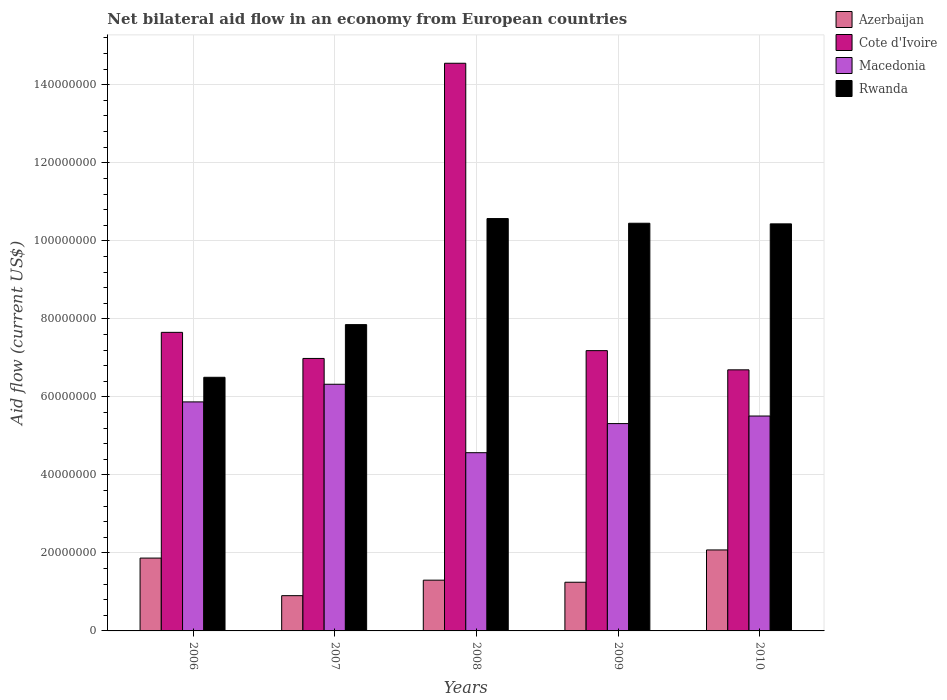How many groups of bars are there?
Ensure brevity in your answer.  5. What is the label of the 1st group of bars from the left?
Your response must be concise. 2006. What is the net bilateral aid flow in Cote d'Ivoire in 2006?
Ensure brevity in your answer.  7.65e+07. Across all years, what is the maximum net bilateral aid flow in Macedonia?
Offer a terse response. 6.32e+07. Across all years, what is the minimum net bilateral aid flow in Cote d'Ivoire?
Ensure brevity in your answer.  6.69e+07. In which year was the net bilateral aid flow in Cote d'Ivoire maximum?
Keep it short and to the point. 2008. What is the total net bilateral aid flow in Rwanda in the graph?
Offer a very short reply. 4.58e+08. What is the difference between the net bilateral aid flow in Cote d'Ivoire in 2006 and that in 2007?
Make the answer very short. 6.69e+06. What is the difference between the net bilateral aid flow in Cote d'Ivoire in 2010 and the net bilateral aid flow in Rwanda in 2006?
Ensure brevity in your answer.  1.91e+06. What is the average net bilateral aid flow in Rwanda per year?
Give a very brief answer. 9.16e+07. In the year 2008, what is the difference between the net bilateral aid flow in Cote d'Ivoire and net bilateral aid flow in Rwanda?
Give a very brief answer. 3.98e+07. What is the ratio of the net bilateral aid flow in Azerbaijan in 2006 to that in 2010?
Offer a very short reply. 0.9. Is the net bilateral aid flow in Rwanda in 2006 less than that in 2008?
Offer a very short reply. Yes. What is the difference between the highest and the second highest net bilateral aid flow in Macedonia?
Your answer should be compact. 4.52e+06. What is the difference between the highest and the lowest net bilateral aid flow in Azerbaijan?
Your answer should be compact. 1.17e+07. Is the sum of the net bilateral aid flow in Cote d'Ivoire in 2009 and 2010 greater than the maximum net bilateral aid flow in Rwanda across all years?
Offer a terse response. Yes. What does the 3rd bar from the left in 2007 represents?
Give a very brief answer. Macedonia. What does the 4th bar from the right in 2006 represents?
Your answer should be compact. Azerbaijan. Are all the bars in the graph horizontal?
Offer a terse response. No. How many years are there in the graph?
Provide a succinct answer. 5. What is the difference between two consecutive major ticks on the Y-axis?
Your answer should be compact. 2.00e+07. Are the values on the major ticks of Y-axis written in scientific E-notation?
Ensure brevity in your answer.  No. Does the graph contain grids?
Ensure brevity in your answer.  Yes. Where does the legend appear in the graph?
Ensure brevity in your answer.  Top right. How are the legend labels stacked?
Your answer should be very brief. Vertical. What is the title of the graph?
Keep it short and to the point. Net bilateral aid flow in an economy from European countries. Does "Isle of Man" appear as one of the legend labels in the graph?
Provide a succinct answer. No. What is the label or title of the X-axis?
Offer a very short reply. Years. What is the label or title of the Y-axis?
Give a very brief answer. Aid flow (current US$). What is the Aid flow (current US$) of Azerbaijan in 2006?
Keep it short and to the point. 1.87e+07. What is the Aid flow (current US$) in Cote d'Ivoire in 2006?
Offer a terse response. 7.65e+07. What is the Aid flow (current US$) in Macedonia in 2006?
Your answer should be very brief. 5.87e+07. What is the Aid flow (current US$) of Rwanda in 2006?
Your answer should be compact. 6.50e+07. What is the Aid flow (current US$) of Azerbaijan in 2007?
Provide a succinct answer. 9.04e+06. What is the Aid flow (current US$) of Cote d'Ivoire in 2007?
Provide a short and direct response. 6.98e+07. What is the Aid flow (current US$) in Macedonia in 2007?
Offer a very short reply. 6.32e+07. What is the Aid flow (current US$) in Rwanda in 2007?
Give a very brief answer. 7.85e+07. What is the Aid flow (current US$) of Azerbaijan in 2008?
Keep it short and to the point. 1.30e+07. What is the Aid flow (current US$) of Cote d'Ivoire in 2008?
Your response must be concise. 1.46e+08. What is the Aid flow (current US$) of Macedonia in 2008?
Offer a terse response. 4.57e+07. What is the Aid flow (current US$) in Rwanda in 2008?
Your answer should be compact. 1.06e+08. What is the Aid flow (current US$) in Azerbaijan in 2009?
Give a very brief answer. 1.25e+07. What is the Aid flow (current US$) of Cote d'Ivoire in 2009?
Offer a terse response. 7.18e+07. What is the Aid flow (current US$) of Macedonia in 2009?
Provide a short and direct response. 5.32e+07. What is the Aid flow (current US$) of Rwanda in 2009?
Provide a succinct answer. 1.05e+08. What is the Aid flow (current US$) in Azerbaijan in 2010?
Offer a very short reply. 2.08e+07. What is the Aid flow (current US$) in Cote d'Ivoire in 2010?
Give a very brief answer. 6.69e+07. What is the Aid flow (current US$) in Macedonia in 2010?
Ensure brevity in your answer.  5.51e+07. What is the Aid flow (current US$) in Rwanda in 2010?
Give a very brief answer. 1.04e+08. Across all years, what is the maximum Aid flow (current US$) in Azerbaijan?
Keep it short and to the point. 2.08e+07. Across all years, what is the maximum Aid flow (current US$) in Cote d'Ivoire?
Offer a terse response. 1.46e+08. Across all years, what is the maximum Aid flow (current US$) of Macedonia?
Offer a terse response. 6.32e+07. Across all years, what is the maximum Aid flow (current US$) of Rwanda?
Your response must be concise. 1.06e+08. Across all years, what is the minimum Aid flow (current US$) of Azerbaijan?
Your response must be concise. 9.04e+06. Across all years, what is the minimum Aid flow (current US$) of Cote d'Ivoire?
Keep it short and to the point. 6.69e+07. Across all years, what is the minimum Aid flow (current US$) in Macedonia?
Provide a short and direct response. 4.57e+07. Across all years, what is the minimum Aid flow (current US$) of Rwanda?
Offer a very short reply. 6.50e+07. What is the total Aid flow (current US$) of Azerbaijan in the graph?
Give a very brief answer. 7.40e+07. What is the total Aid flow (current US$) of Cote d'Ivoire in the graph?
Your answer should be very brief. 4.31e+08. What is the total Aid flow (current US$) of Macedonia in the graph?
Your answer should be compact. 2.76e+08. What is the total Aid flow (current US$) in Rwanda in the graph?
Provide a succinct answer. 4.58e+08. What is the difference between the Aid flow (current US$) in Azerbaijan in 2006 and that in 2007?
Give a very brief answer. 9.63e+06. What is the difference between the Aid flow (current US$) of Cote d'Ivoire in 2006 and that in 2007?
Give a very brief answer. 6.69e+06. What is the difference between the Aid flow (current US$) in Macedonia in 2006 and that in 2007?
Your response must be concise. -4.52e+06. What is the difference between the Aid flow (current US$) in Rwanda in 2006 and that in 2007?
Give a very brief answer. -1.35e+07. What is the difference between the Aid flow (current US$) in Azerbaijan in 2006 and that in 2008?
Ensure brevity in your answer.  5.66e+06. What is the difference between the Aid flow (current US$) in Cote d'Ivoire in 2006 and that in 2008?
Provide a succinct answer. -6.90e+07. What is the difference between the Aid flow (current US$) of Macedonia in 2006 and that in 2008?
Provide a succinct answer. 1.30e+07. What is the difference between the Aid flow (current US$) of Rwanda in 2006 and that in 2008?
Make the answer very short. -4.07e+07. What is the difference between the Aid flow (current US$) in Azerbaijan in 2006 and that in 2009?
Make the answer very short. 6.19e+06. What is the difference between the Aid flow (current US$) in Cote d'Ivoire in 2006 and that in 2009?
Your answer should be very brief. 4.69e+06. What is the difference between the Aid flow (current US$) of Macedonia in 2006 and that in 2009?
Keep it short and to the point. 5.56e+06. What is the difference between the Aid flow (current US$) of Rwanda in 2006 and that in 2009?
Your response must be concise. -3.95e+07. What is the difference between the Aid flow (current US$) in Azerbaijan in 2006 and that in 2010?
Provide a short and direct response. -2.09e+06. What is the difference between the Aid flow (current US$) in Cote d'Ivoire in 2006 and that in 2010?
Provide a short and direct response. 9.61e+06. What is the difference between the Aid flow (current US$) in Macedonia in 2006 and that in 2010?
Keep it short and to the point. 3.62e+06. What is the difference between the Aid flow (current US$) of Rwanda in 2006 and that in 2010?
Your answer should be compact. -3.93e+07. What is the difference between the Aid flow (current US$) of Azerbaijan in 2007 and that in 2008?
Make the answer very short. -3.97e+06. What is the difference between the Aid flow (current US$) of Cote d'Ivoire in 2007 and that in 2008?
Provide a short and direct response. -7.57e+07. What is the difference between the Aid flow (current US$) of Macedonia in 2007 and that in 2008?
Give a very brief answer. 1.75e+07. What is the difference between the Aid flow (current US$) of Rwanda in 2007 and that in 2008?
Your answer should be very brief. -2.72e+07. What is the difference between the Aid flow (current US$) of Azerbaijan in 2007 and that in 2009?
Your answer should be very brief. -3.44e+06. What is the difference between the Aid flow (current US$) in Macedonia in 2007 and that in 2009?
Keep it short and to the point. 1.01e+07. What is the difference between the Aid flow (current US$) of Rwanda in 2007 and that in 2009?
Give a very brief answer. -2.60e+07. What is the difference between the Aid flow (current US$) of Azerbaijan in 2007 and that in 2010?
Ensure brevity in your answer.  -1.17e+07. What is the difference between the Aid flow (current US$) of Cote d'Ivoire in 2007 and that in 2010?
Keep it short and to the point. 2.92e+06. What is the difference between the Aid flow (current US$) of Macedonia in 2007 and that in 2010?
Offer a very short reply. 8.14e+06. What is the difference between the Aid flow (current US$) of Rwanda in 2007 and that in 2010?
Offer a terse response. -2.58e+07. What is the difference between the Aid flow (current US$) of Azerbaijan in 2008 and that in 2009?
Offer a terse response. 5.30e+05. What is the difference between the Aid flow (current US$) of Cote d'Ivoire in 2008 and that in 2009?
Your response must be concise. 7.37e+07. What is the difference between the Aid flow (current US$) of Macedonia in 2008 and that in 2009?
Keep it short and to the point. -7.46e+06. What is the difference between the Aid flow (current US$) in Rwanda in 2008 and that in 2009?
Provide a succinct answer. 1.20e+06. What is the difference between the Aid flow (current US$) of Azerbaijan in 2008 and that in 2010?
Offer a very short reply. -7.75e+06. What is the difference between the Aid flow (current US$) of Cote d'Ivoire in 2008 and that in 2010?
Your answer should be very brief. 7.86e+07. What is the difference between the Aid flow (current US$) of Macedonia in 2008 and that in 2010?
Your answer should be very brief. -9.40e+06. What is the difference between the Aid flow (current US$) of Rwanda in 2008 and that in 2010?
Give a very brief answer. 1.36e+06. What is the difference between the Aid flow (current US$) in Azerbaijan in 2009 and that in 2010?
Provide a succinct answer. -8.28e+06. What is the difference between the Aid flow (current US$) of Cote d'Ivoire in 2009 and that in 2010?
Give a very brief answer. 4.92e+06. What is the difference between the Aid flow (current US$) of Macedonia in 2009 and that in 2010?
Provide a succinct answer. -1.94e+06. What is the difference between the Aid flow (current US$) in Azerbaijan in 2006 and the Aid flow (current US$) in Cote d'Ivoire in 2007?
Ensure brevity in your answer.  -5.12e+07. What is the difference between the Aid flow (current US$) in Azerbaijan in 2006 and the Aid flow (current US$) in Macedonia in 2007?
Your answer should be very brief. -4.46e+07. What is the difference between the Aid flow (current US$) of Azerbaijan in 2006 and the Aid flow (current US$) of Rwanda in 2007?
Make the answer very short. -5.98e+07. What is the difference between the Aid flow (current US$) in Cote d'Ivoire in 2006 and the Aid flow (current US$) in Macedonia in 2007?
Keep it short and to the point. 1.33e+07. What is the difference between the Aid flow (current US$) in Cote d'Ivoire in 2006 and the Aid flow (current US$) in Rwanda in 2007?
Provide a succinct answer. -1.98e+06. What is the difference between the Aid flow (current US$) of Macedonia in 2006 and the Aid flow (current US$) of Rwanda in 2007?
Your answer should be very brief. -1.98e+07. What is the difference between the Aid flow (current US$) of Azerbaijan in 2006 and the Aid flow (current US$) of Cote d'Ivoire in 2008?
Your answer should be very brief. -1.27e+08. What is the difference between the Aid flow (current US$) in Azerbaijan in 2006 and the Aid flow (current US$) in Macedonia in 2008?
Your response must be concise. -2.70e+07. What is the difference between the Aid flow (current US$) of Azerbaijan in 2006 and the Aid flow (current US$) of Rwanda in 2008?
Your answer should be compact. -8.70e+07. What is the difference between the Aid flow (current US$) of Cote d'Ivoire in 2006 and the Aid flow (current US$) of Macedonia in 2008?
Offer a very short reply. 3.08e+07. What is the difference between the Aid flow (current US$) in Cote d'Ivoire in 2006 and the Aid flow (current US$) in Rwanda in 2008?
Offer a very short reply. -2.92e+07. What is the difference between the Aid flow (current US$) of Macedonia in 2006 and the Aid flow (current US$) of Rwanda in 2008?
Offer a very short reply. -4.70e+07. What is the difference between the Aid flow (current US$) in Azerbaijan in 2006 and the Aid flow (current US$) in Cote d'Ivoire in 2009?
Your answer should be compact. -5.32e+07. What is the difference between the Aid flow (current US$) of Azerbaijan in 2006 and the Aid flow (current US$) of Macedonia in 2009?
Keep it short and to the point. -3.45e+07. What is the difference between the Aid flow (current US$) in Azerbaijan in 2006 and the Aid flow (current US$) in Rwanda in 2009?
Your answer should be compact. -8.58e+07. What is the difference between the Aid flow (current US$) in Cote d'Ivoire in 2006 and the Aid flow (current US$) in Macedonia in 2009?
Ensure brevity in your answer.  2.34e+07. What is the difference between the Aid flow (current US$) in Cote d'Ivoire in 2006 and the Aid flow (current US$) in Rwanda in 2009?
Make the answer very short. -2.80e+07. What is the difference between the Aid flow (current US$) of Macedonia in 2006 and the Aid flow (current US$) of Rwanda in 2009?
Make the answer very short. -4.58e+07. What is the difference between the Aid flow (current US$) of Azerbaijan in 2006 and the Aid flow (current US$) of Cote d'Ivoire in 2010?
Offer a terse response. -4.83e+07. What is the difference between the Aid flow (current US$) of Azerbaijan in 2006 and the Aid flow (current US$) of Macedonia in 2010?
Your answer should be very brief. -3.64e+07. What is the difference between the Aid flow (current US$) in Azerbaijan in 2006 and the Aid flow (current US$) in Rwanda in 2010?
Give a very brief answer. -8.57e+07. What is the difference between the Aid flow (current US$) of Cote d'Ivoire in 2006 and the Aid flow (current US$) of Macedonia in 2010?
Ensure brevity in your answer.  2.14e+07. What is the difference between the Aid flow (current US$) in Cote d'Ivoire in 2006 and the Aid flow (current US$) in Rwanda in 2010?
Your response must be concise. -2.78e+07. What is the difference between the Aid flow (current US$) of Macedonia in 2006 and the Aid flow (current US$) of Rwanda in 2010?
Provide a succinct answer. -4.56e+07. What is the difference between the Aid flow (current US$) in Azerbaijan in 2007 and the Aid flow (current US$) in Cote d'Ivoire in 2008?
Ensure brevity in your answer.  -1.36e+08. What is the difference between the Aid flow (current US$) of Azerbaijan in 2007 and the Aid flow (current US$) of Macedonia in 2008?
Offer a very short reply. -3.66e+07. What is the difference between the Aid flow (current US$) of Azerbaijan in 2007 and the Aid flow (current US$) of Rwanda in 2008?
Keep it short and to the point. -9.67e+07. What is the difference between the Aid flow (current US$) in Cote d'Ivoire in 2007 and the Aid flow (current US$) in Macedonia in 2008?
Provide a succinct answer. 2.42e+07. What is the difference between the Aid flow (current US$) in Cote d'Ivoire in 2007 and the Aid flow (current US$) in Rwanda in 2008?
Offer a very short reply. -3.59e+07. What is the difference between the Aid flow (current US$) in Macedonia in 2007 and the Aid flow (current US$) in Rwanda in 2008?
Offer a terse response. -4.25e+07. What is the difference between the Aid flow (current US$) in Azerbaijan in 2007 and the Aid flow (current US$) in Cote d'Ivoire in 2009?
Offer a very short reply. -6.28e+07. What is the difference between the Aid flow (current US$) of Azerbaijan in 2007 and the Aid flow (current US$) of Macedonia in 2009?
Make the answer very short. -4.41e+07. What is the difference between the Aid flow (current US$) of Azerbaijan in 2007 and the Aid flow (current US$) of Rwanda in 2009?
Your response must be concise. -9.55e+07. What is the difference between the Aid flow (current US$) of Cote d'Ivoire in 2007 and the Aid flow (current US$) of Macedonia in 2009?
Keep it short and to the point. 1.67e+07. What is the difference between the Aid flow (current US$) in Cote d'Ivoire in 2007 and the Aid flow (current US$) in Rwanda in 2009?
Your answer should be compact. -3.47e+07. What is the difference between the Aid flow (current US$) of Macedonia in 2007 and the Aid flow (current US$) of Rwanda in 2009?
Provide a short and direct response. -4.13e+07. What is the difference between the Aid flow (current US$) of Azerbaijan in 2007 and the Aid flow (current US$) of Cote d'Ivoire in 2010?
Your answer should be compact. -5.79e+07. What is the difference between the Aid flow (current US$) in Azerbaijan in 2007 and the Aid flow (current US$) in Macedonia in 2010?
Offer a terse response. -4.60e+07. What is the difference between the Aid flow (current US$) of Azerbaijan in 2007 and the Aid flow (current US$) of Rwanda in 2010?
Make the answer very short. -9.53e+07. What is the difference between the Aid flow (current US$) of Cote d'Ivoire in 2007 and the Aid flow (current US$) of Macedonia in 2010?
Keep it short and to the point. 1.48e+07. What is the difference between the Aid flow (current US$) of Cote d'Ivoire in 2007 and the Aid flow (current US$) of Rwanda in 2010?
Offer a terse response. -3.45e+07. What is the difference between the Aid flow (current US$) in Macedonia in 2007 and the Aid flow (current US$) in Rwanda in 2010?
Give a very brief answer. -4.11e+07. What is the difference between the Aid flow (current US$) in Azerbaijan in 2008 and the Aid flow (current US$) in Cote d'Ivoire in 2009?
Ensure brevity in your answer.  -5.88e+07. What is the difference between the Aid flow (current US$) in Azerbaijan in 2008 and the Aid flow (current US$) in Macedonia in 2009?
Your response must be concise. -4.01e+07. What is the difference between the Aid flow (current US$) in Azerbaijan in 2008 and the Aid flow (current US$) in Rwanda in 2009?
Provide a succinct answer. -9.15e+07. What is the difference between the Aid flow (current US$) of Cote d'Ivoire in 2008 and the Aid flow (current US$) of Macedonia in 2009?
Provide a short and direct response. 9.24e+07. What is the difference between the Aid flow (current US$) of Cote d'Ivoire in 2008 and the Aid flow (current US$) of Rwanda in 2009?
Your answer should be very brief. 4.10e+07. What is the difference between the Aid flow (current US$) of Macedonia in 2008 and the Aid flow (current US$) of Rwanda in 2009?
Your answer should be compact. -5.88e+07. What is the difference between the Aid flow (current US$) of Azerbaijan in 2008 and the Aid flow (current US$) of Cote d'Ivoire in 2010?
Keep it short and to the point. -5.39e+07. What is the difference between the Aid flow (current US$) of Azerbaijan in 2008 and the Aid flow (current US$) of Macedonia in 2010?
Give a very brief answer. -4.21e+07. What is the difference between the Aid flow (current US$) in Azerbaijan in 2008 and the Aid flow (current US$) in Rwanda in 2010?
Provide a succinct answer. -9.13e+07. What is the difference between the Aid flow (current US$) of Cote d'Ivoire in 2008 and the Aid flow (current US$) of Macedonia in 2010?
Make the answer very short. 9.04e+07. What is the difference between the Aid flow (current US$) of Cote d'Ivoire in 2008 and the Aid flow (current US$) of Rwanda in 2010?
Your response must be concise. 4.12e+07. What is the difference between the Aid flow (current US$) of Macedonia in 2008 and the Aid flow (current US$) of Rwanda in 2010?
Offer a terse response. -5.87e+07. What is the difference between the Aid flow (current US$) in Azerbaijan in 2009 and the Aid flow (current US$) in Cote d'Ivoire in 2010?
Provide a succinct answer. -5.44e+07. What is the difference between the Aid flow (current US$) in Azerbaijan in 2009 and the Aid flow (current US$) in Macedonia in 2010?
Give a very brief answer. -4.26e+07. What is the difference between the Aid flow (current US$) in Azerbaijan in 2009 and the Aid flow (current US$) in Rwanda in 2010?
Provide a succinct answer. -9.19e+07. What is the difference between the Aid flow (current US$) of Cote d'Ivoire in 2009 and the Aid flow (current US$) of Macedonia in 2010?
Provide a short and direct response. 1.68e+07. What is the difference between the Aid flow (current US$) in Cote d'Ivoire in 2009 and the Aid flow (current US$) in Rwanda in 2010?
Provide a short and direct response. -3.25e+07. What is the difference between the Aid flow (current US$) of Macedonia in 2009 and the Aid flow (current US$) of Rwanda in 2010?
Your answer should be very brief. -5.12e+07. What is the average Aid flow (current US$) of Azerbaijan per year?
Make the answer very short. 1.48e+07. What is the average Aid flow (current US$) of Cote d'Ivoire per year?
Provide a succinct answer. 8.61e+07. What is the average Aid flow (current US$) of Macedonia per year?
Your answer should be compact. 5.52e+07. What is the average Aid flow (current US$) in Rwanda per year?
Give a very brief answer. 9.16e+07. In the year 2006, what is the difference between the Aid flow (current US$) of Azerbaijan and Aid flow (current US$) of Cote d'Ivoire?
Ensure brevity in your answer.  -5.79e+07. In the year 2006, what is the difference between the Aid flow (current US$) of Azerbaijan and Aid flow (current US$) of Macedonia?
Ensure brevity in your answer.  -4.00e+07. In the year 2006, what is the difference between the Aid flow (current US$) of Azerbaijan and Aid flow (current US$) of Rwanda?
Your answer should be very brief. -4.64e+07. In the year 2006, what is the difference between the Aid flow (current US$) of Cote d'Ivoire and Aid flow (current US$) of Macedonia?
Your response must be concise. 1.78e+07. In the year 2006, what is the difference between the Aid flow (current US$) of Cote d'Ivoire and Aid flow (current US$) of Rwanda?
Provide a short and direct response. 1.15e+07. In the year 2006, what is the difference between the Aid flow (current US$) of Macedonia and Aid flow (current US$) of Rwanda?
Provide a short and direct response. -6.31e+06. In the year 2007, what is the difference between the Aid flow (current US$) in Azerbaijan and Aid flow (current US$) in Cote d'Ivoire?
Provide a succinct answer. -6.08e+07. In the year 2007, what is the difference between the Aid flow (current US$) of Azerbaijan and Aid flow (current US$) of Macedonia?
Offer a very short reply. -5.42e+07. In the year 2007, what is the difference between the Aid flow (current US$) of Azerbaijan and Aid flow (current US$) of Rwanda?
Offer a terse response. -6.95e+07. In the year 2007, what is the difference between the Aid flow (current US$) of Cote d'Ivoire and Aid flow (current US$) of Macedonia?
Your answer should be very brief. 6.62e+06. In the year 2007, what is the difference between the Aid flow (current US$) of Cote d'Ivoire and Aid flow (current US$) of Rwanda?
Provide a succinct answer. -8.67e+06. In the year 2007, what is the difference between the Aid flow (current US$) of Macedonia and Aid flow (current US$) of Rwanda?
Offer a terse response. -1.53e+07. In the year 2008, what is the difference between the Aid flow (current US$) of Azerbaijan and Aid flow (current US$) of Cote d'Ivoire?
Your answer should be very brief. -1.33e+08. In the year 2008, what is the difference between the Aid flow (current US$) of Azerbaijan and Aid flow (current US$) of Macedonia?
Ensure brevity in your answer.  -3.27e+07. In the year 2008, what is the difference between the Aid flow (current US$) of Azerbaijan and Aid flow (current US$) of Rwanda?
Your answer should be compact. -9.27e+07. In the year 2008, what is the difference between the Aid flow (current US$) in Cote d'Ivoire and Aid flow (current US$) in Macedonia?
Keep it short and to the point. 9.98e+07. In the year 2008, what is the difference between the Aid flow (current US$) in Cote d'Ivoire and Aid flow (current US$) in Rwanda?
Your answer should be very brief. 3.98e+07. In the year 2008, what is the difference between the Aid flow (current US$) in Macedonia and Aid flow (current US$) in Rwanda?
Provide a succinct answer. -6.00e+07. In the year 2009, what is the difference between the Aid flow (current US$) of Azerbaijan and Aid flow (current US$) of Cote d'Ivoire?
Make the answer very short. -5.94e+07. In the year 2009, what is the difference between the Aid flow (current US$) in Azerbaijan and Aid flow (current US$) in Macedonia?
Give a very brief answer. -4.07e+07. In the year 2009, what is the difference between the Aid flow (current US$) of Azerbaijan and Aid flow (current US$) of Rwanda?
Your answer should be very brief. -9.20e+07. In the year 2009, what is the difference between the Aid flow (current US$) in Cote d'Ivoire and Aid flow (current US$) in Macedonia?
Keep it short and to the point. 1.87e+07. In the year 2009, what is the difference between the Aid flow (current US$) in Cote d'Ivoire and Aid flow (current US$) in Rwanda?
Make the answer very short. -3.27e+07. In the year 2009, what is the difference between the Aid flow (current US$) of Macedonia and Aid flow (current US$) of Rwanda?
Provide a succinct answer. -5.14e+07. In the year 2010, what is the difference between the Aid flow (current US$) of Azerbaijan and Aid flow (current US$) of Cote d'Ivoire?
Ensure brevity in your answer.  -4.62e+07. In the year 2010, what is the difference between the Aid flow (current US$) of Azerbaijan and Aid flow (current US$) of Macedonia?
Your answer should be very brief. -3.43e+07. In the year 2010, what is the difference between the Aid flow (current US$) in Azerbaijan and Aid flow (current US$) in Rwanda?
Offer a very short reply. -8.36e+07. In the year 2010, what is the difference between the Aid flow (current US$) of Cote d'Ivoire and Aid flow (current US$) of Macedonia?
Offer a terse response. 1.18e+07. In the year 2010, what is the difference between the Aid flow (current US$) in Cote d'Ivoire and Aid flow (current US$) in Rwanda?
Ensure brevity in your answer.  -3.74e+07. In the year 2010, what is the difference between the Aid flow (current US$) of Macedonia and Aid flow (current US$) of Rwanda?
Offer a very short reply. -4.93e+07. What is the ratio of the Aid flow (current US$) of Azerbaijan in 2006 to that in 2007?
Your answer should be very brief. 2.07. What is the ratio of the Aid flow (current US$) of Cote d'Ivoire in 2006 to that in 2007?
Give a very brief answer. 1.1. What is the ratio of the Aid flow (current US$) in Macedonia in 2006 to that in 2007?
Ensure brevity in your answer.  0.93. What is the ratio of the Aid flow (current US$) in Rwanda in 2006 to that in 2007?
Offer a terse response. 0.83. What is the ratio of the Aid flow (current US$) of Azerbaijan in 2006 to that in 2008?
Ensure brevity in your answer.  1.44. What is the ratio of the Aid flow (current US$) of Cote d'Ivoire in 2006 to that in 2008?
Ensure brevity in your answer.  0.53. What is the ratio of the Aid flow (current US$) in Macedonia in 2006 to that in 2008?
Make the answer very short. 1.28. What is the ratio of the Aid flow (current US$) of Rwanda in 2006 to that in 2008?
Your answer should be very brief. 0.62. What is the ratio of the Aid flow (current US$) of Azerbaijan in 2006 to that in 2009?
Offer a terse response. 1.5. What is the ratio of the Aid flow (current US$) of Cote d'Ivoire in 2006 to that in 2009?
Ensure brevity in your answer.  1.07. What is the ratio of the Aid flow (current US$) of Macedonia in 2006 to that in 2009?
Your answer should be compact. 1.1. What is the ratio of the Aid flow (current US$) in Rwanda in 2006 to that in 2009?
Make the answer very short. 0.62. What is the ratio of the Aid flow (current US$) of Azerbaijan in 2006 to that in 2010?
Provide a succinct answer. 0.9. What is the ratio of the Aid flow (current US$) in Cote d'Ivoire in 2006 to that in 2010?
Offer a very short reply. 1.14. What is the ratio of the Aid flow (current US$) in Macedonia in 2006 to that in 2010?
Your answer should be very brief. 1.07. What is the ratio of the Aid flow (current US$) of Rwanda in 2006 to that in 2010?
Your answer should be very brief. 0.62. What is the ratio of the Aid flow (current US$) in Azerbaijan in 2007 to that in 2008?
Provide a short and direct response. 0.69. What is the ratio of the Aid flow (current US$) of Cote d'Ivoire in 2007 to that in 2008?
Provide a short and direct response. 0.48. What is the ratio of the Aid flow (current US$) of Macedonia in 2007 to that in 2008?
Offer a very short reply. 1.38. What is the ratio of the Aid flow (current US$) in Rwanda in 2007 to that in 2008?
Your answer should be compact. 0.74. What is the ratio of the Aid flow (current US$) in Azerbaijan in 2007 to that in 2009?
Your answer should be compact. 0.72. What is the ratio of the Aid flow (current US$) in Cote d'Ivoire in 2007 to that in 2009?
Provide a succinct answer. 0.97. What is the ratio of the Aid flow (current US$) of Macedonia in 2007 to that in 2009?
Your response must be concise. 1.19. What is the ratio of the Aid flow (current US$) in Rwanda in 2007 to that in 2009?
Offer a terse response. 0.75. What is the ratio of the Aid flow (current US$) of Azerbaijan in 2007 to that in 2010?
Give a very brief answer. 0.44. What is the ratio of the Aid flow (current US$) of Cote d'Ivoire in 2007 to that in 2010?
Your answer should be compact. 1.04. What is the ratio of the Aid flow (current US$) of Macedonia in 2007 to that in 2010?
Your answer should be compact. 1.15. What is the ratio of the Aid flow (current US$) in Rwanda in 2007 to that in 2010?
Make the answer very short. 0.75. What is the ratio of the Aid flow (current US$) in Azerbaijan in 2008 to that in 2009?
Offer a terse response. 1.04. What is the ratio of the Aid flow (current US$) in Cote d'Ivoire in 2008 to that in 2009?
Give a very brief answer. 2.03. What is the ratio of the Aid flow (current US$) of Macedonia in 2008 to that in 2009?
Your answer should be very brief. 0.86. What is the ratio of the Aid flow (current US$) of Rwanda in 2008 to that in 2009?
Offer a very short reply. 1.01. What is the ratio of the Aid flow (current US$) in Azerbaijan in 2008 to that in 2010?
Your response must be concise. 0.63. What is the ratio of the Aid flow (current US$) in Cote d'Ivoire in 2008 to that in 2010?
Give a very brief answer. 2.17. What is the ratio of the Aid flow (current US$) in Macedonia in 2008 to that in 2010?
Give a very brief answer. 0.83. What is the ratio of the Aid flow (current US$) of Rwanda in 2008 to that in 2010?
Offer a terse response. 1.01. What is the ratio of the Aid flow (current US$) of Azerbaijan in 2009 to that in 2010?
Provide a short and direct response. 0.6. What is the ratio of the Aid flow (current US$) of Cote d'Ivoire in 2009 to that in 2010?
Offer a very short reply. 1.07. What is the ratio of the Aid flow (current US$) of Macedonia in 2009 to that in 2010?
Offer a very short reply. 0.96. What is the ratio of the Aid flow (current US$) in Rwanda in 2009 to that in 2010?
Keep it short and to the point. 1. What is the difference between the highest and the second highest Aid flow (current US$) of Azerbaijan?
Keep it short and to the point. 2.09e+06. What is the difference between the highest and the second highest Aid flow (current US$) of Cote d'Ivoire?
Offer a terse response. 6.90e+07. What is the difference between the highest and the second highest Aid flow (current US$) of Macedonia?
Offer a terse response. 4.52e+06. What is the difference between the highest and the second highest Aid flow (current US$) in Rwanda?
Make the answer very short. 1.20e+06. What is the difference between the highest and the lowest Aid flow (current US$) in Azerbaijan?
Keep it short and to the point. 1.17e+07. What is the difference between the highest and the lowest Aid flow (current US$) in Cote d'Ivoire?
Offer a very short reply. 7.86e+07. What is the difference between the highest and the lowest Aid flow (current US$) of Macedonia?
Provide a succinct answer. 1.75e+07. What is the difference between the highest and the lowest Aid flow (current US$) in Rwanda?
Your answer should be very brief. 4.07e+07. 